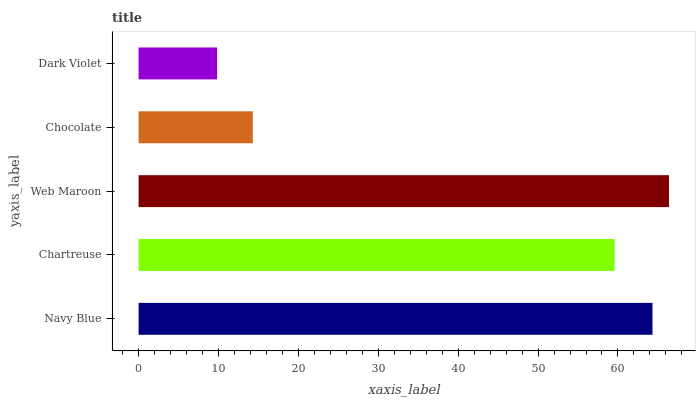Is Dark Violet the minimum?
Answer yes or no. Yes. Is Web Maroon the maximum?
Answer yes or no. Yes. Is Chartreuse the minimum?
Answer yes or no. No. Is Chartreuse the maximum?
Answer yes or no. No. Is Navy Blue greater than Chartreuse?
Answer yes or no. Yes. Is Chartreuse less than Navy Blue?
Answer yes or no. Yes. Is Chartreuse greater than Navy Blue?
Answer yes or no. No. Is Navy Blue less than Chartreuse?
Answer yes or no. No. Is Chartreuse the high median?
Answer yes or no. Yes. Is Chartreuse the low median?
Answer yes or no. Yes. Is Navy Blue the high median?
Answer yes or no. No. Is Navy Blue the low median?
Answer yes or no. No. 